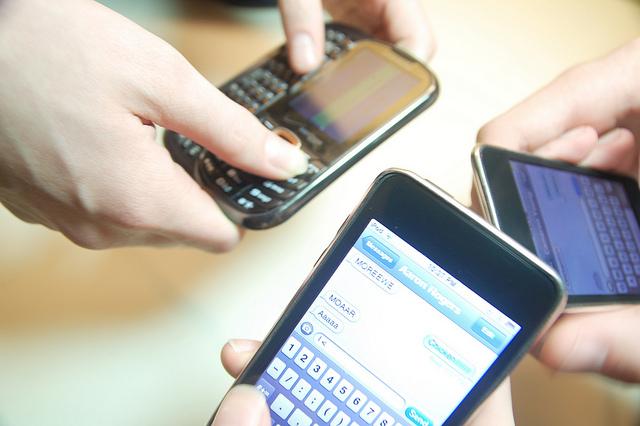Which phone is the oldest?
Quick response, please. Left. How many phones do you see?
Concise answer only. 3. Does the top hand belong to the same person as the bottom hand?
Keep it brief. No. Which devices show keypads?
Short answer required. Phones. 